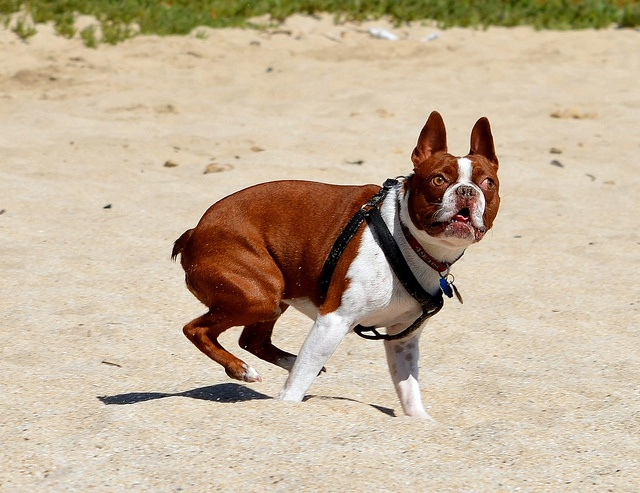Describe the objects in this image and their specific colors. I can see a dog in olive, maroon, black, lightgray, and brown tones in this image. 